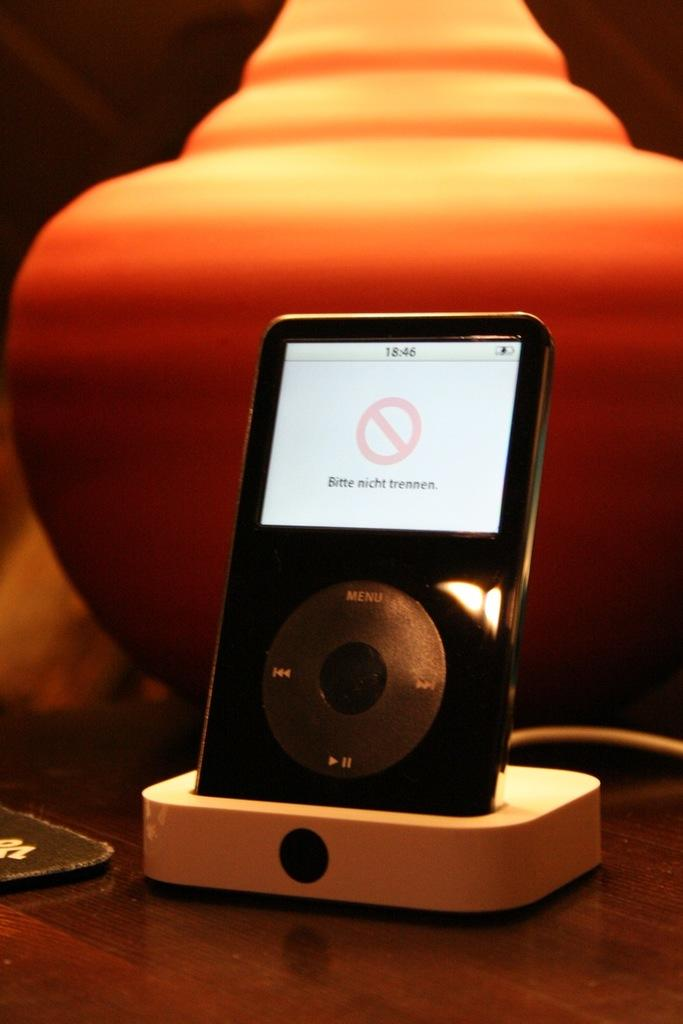What electronic device is visible in the image? There is an iPod in the image. What feature does the iPod have? The iPod has a screen. Is there anything connected to the iPod? Yes, there is a wire associated with the iPod. What else can be seen on the table in the image? There is an object on the table in the image. Is there a slope in the image where the iPod is placed? No, there is no slope visible in the image; the iPod is placed on a flat surface. Can you see any straws near the iPod? No, there are no straws present in the image. 